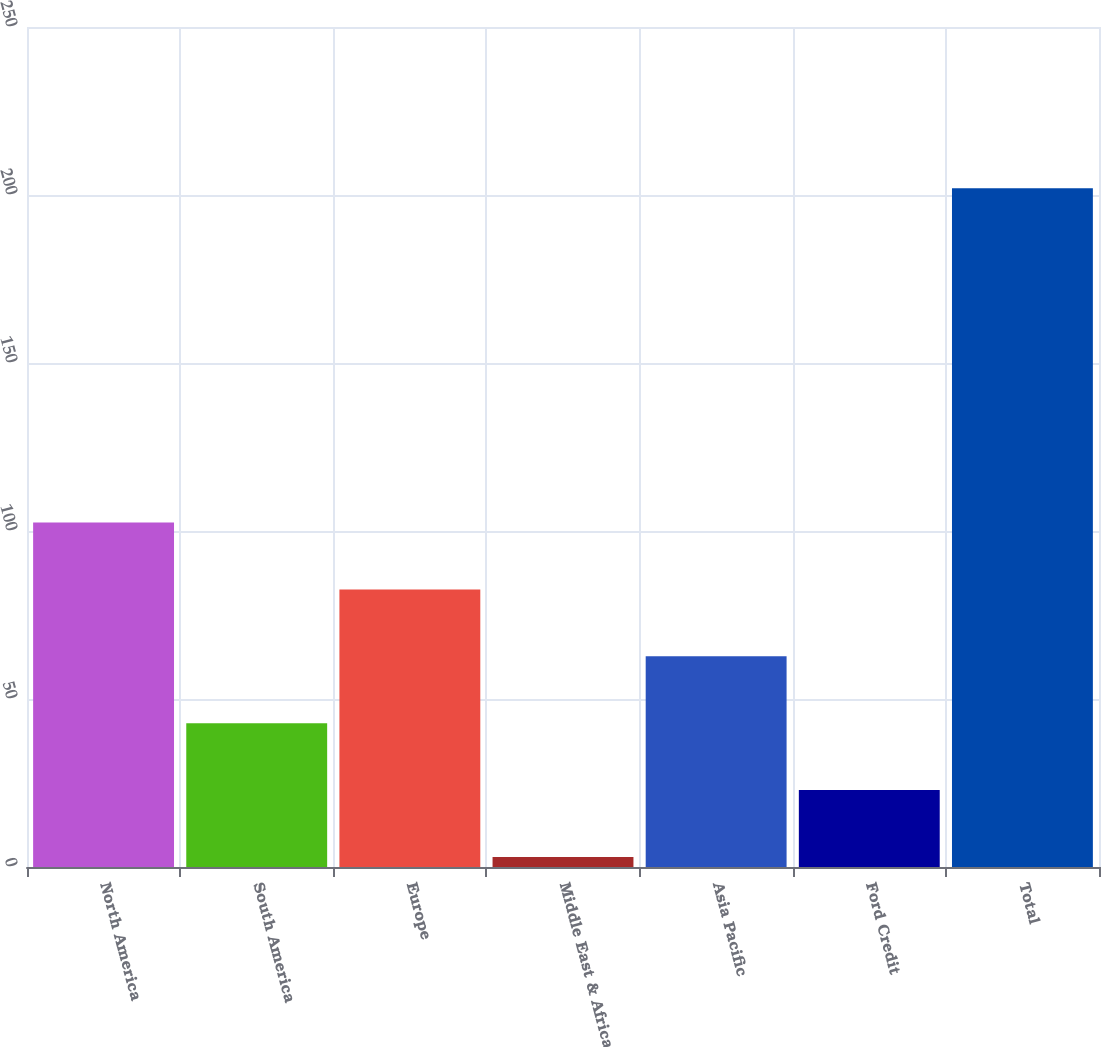<chart> <loc_0><loc_0><loc_500><loc_500><bar_chart><fcel>North America<fcel>South America<fcel>Europe<fcel>Middle East & Africa<fcel>Asia Pacific<fcel>Ford Credit<fcel>Total<nl><fcel>102.5<fcel>42.8<fcel>82.6<fcel>3<fcel>62.7<fcel>22.9<fcel>202<nl></chart> 